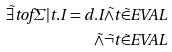Convert formula to latex. <formula><loc_0><loc_0><loc_500><loc_500>\tilde { \exists } t o f \Sigma | t . I = d . I \tilde { \wedge } t \tilde { \in } E V A L \\ \tilde { \wedge } \tilde { \neg } t \tilde { \in } E V A L</formula> 